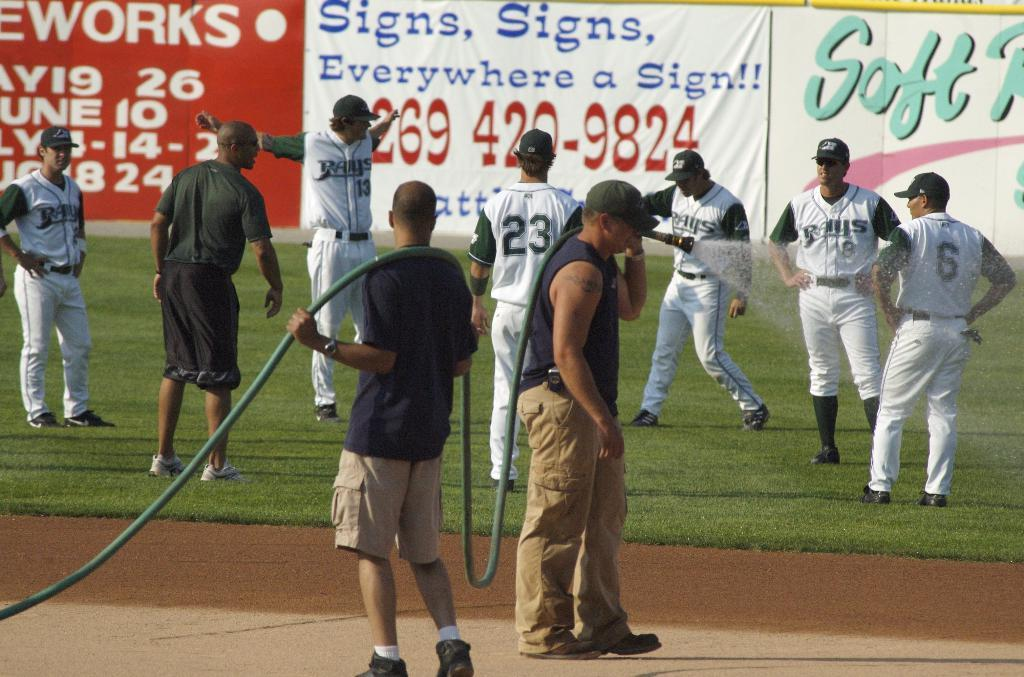<image>
Share a concise interpretation of the image provided. A crew to two men hose down the infield at a Rays Baseball game. 